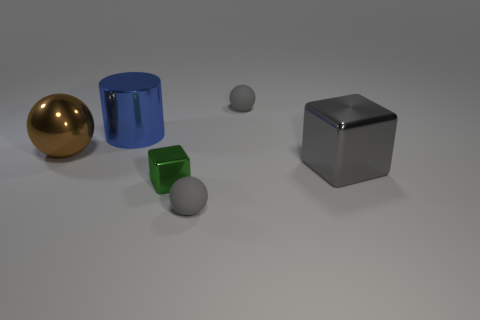There is a small sphere that is in front of the large shiny object that is left of the large metallic cylinder; what is it made of?
Make the answer very short. Rubber. There is a gray metal thing; are there any tiny rubber spheres right of it?
Offer a terse response. No. Is the number of large cubes in front of the large brown thing greater than the number of green blocks?
Provide a short and direct response. No. Is there a tiny shiny object of the same color as the big metallic cylinder?
Provide a short and direct response. No. There is a block that is the same size as the metallic ball; what is its color?
Provide a succinct answer. Gray. There is a metal thing behind the brown ball; are there any shiny objects to the left of it?
Ensure brevity in your answer.  Yes. What material is the small ball in front of the green metal object?
Provide a succinct answer. Rubber. Is the gray thing that is behind the large gray metal block made of the same material as the large object behind the brown ball?
Your answer should be very brief. No. Are there the same number of cubes that are to the right of the large shiny block and brown balls that are in front of the large blue cylinder?
Offer a very short reply. No. What number of large things have the same material as the tiny block?
Make the answer very short. 3. 